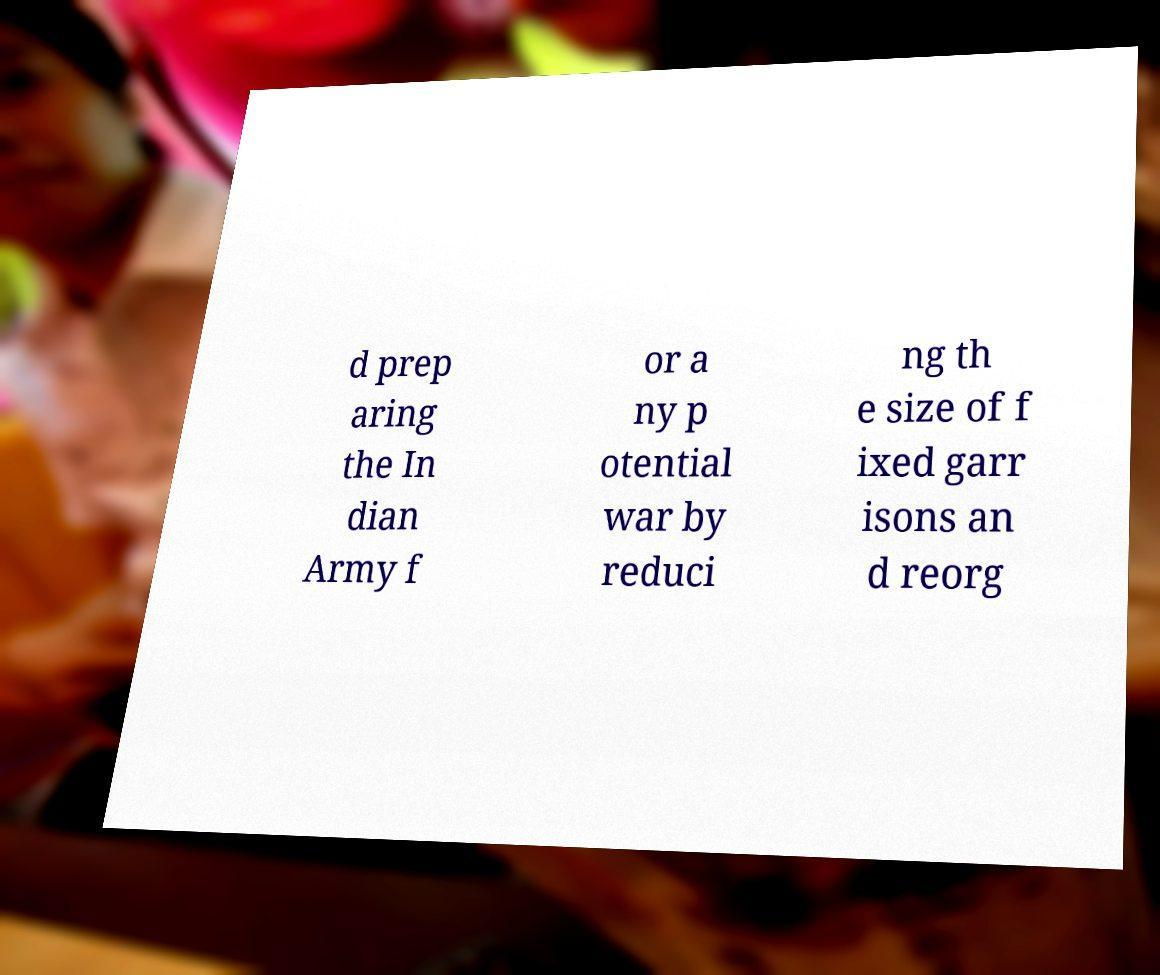Could you extract and type out the text from this image? d prep aring the In dian Army f or a ny p otential war by reduci ng th e size of f ixed garr isons an d reorg 